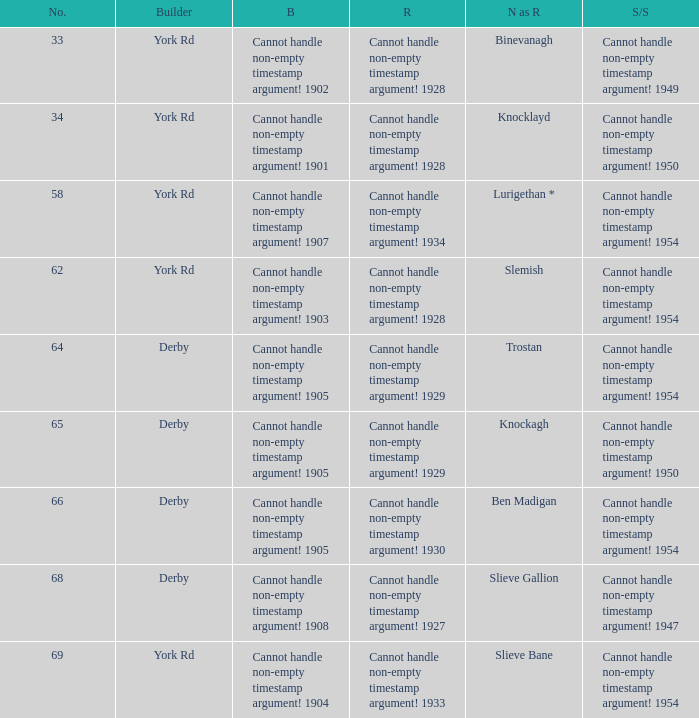Which Rebuilt has a Name as rebuilt of binevanagh? Cannot handle non-empty timestamp argument! 1928. 